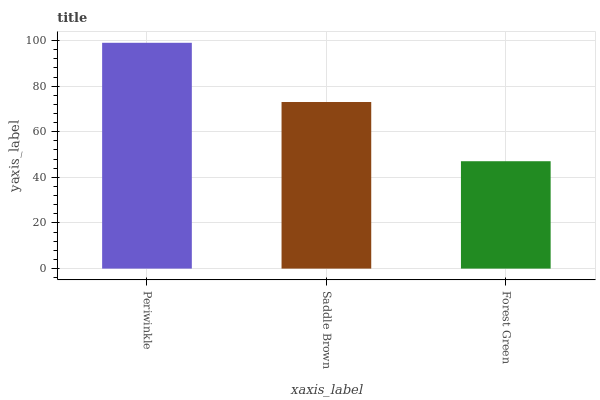Is Forest Green the minimum?
Answer yes or no. Yes. Is Periwinkle the maximum?
Answer yes or no. Yes. Is Saddle Brown the minimum?
Answer yes or no. No. Is Saddle Brown the maximum?
Answer yes or no. No. Is Periwinkle greater than Saddle Brown?
Answer yes or no. Yes. Is Saddle Brown less than Periwinkle?
Answer yes or no. Yes. Is Saddle Brown greater than Periwinkle?
Answer yes or no. No. Is Periwinkle less than Saddle Brown?
Answer yes or no. No. Is Saddle Brown the high median?
Answer yes or no. Yes. Is Saddle Brown the low median?
Answer yes or no. Yes. Is Forest Green the high median?
Answer yes or no. No. Is Periwinkle the low median?
Answer yes or no. No. 